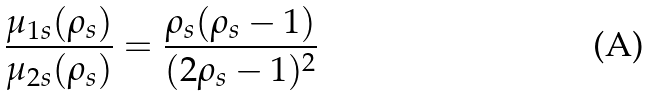Convert formula to latex. <formula><loc_0><loc_0><loc_500><loc_500>\frac { \mu _ { 1 s } ( \rho _ { s } ) } { \mu _ { 2 s } ( \rho _ { s } ) } = \frac { \rho _ { s } ( \rho _ { s } - 1 ) } { ( 2 \rho _ { s } - 1 ) ^ { 2 } }</formula> 